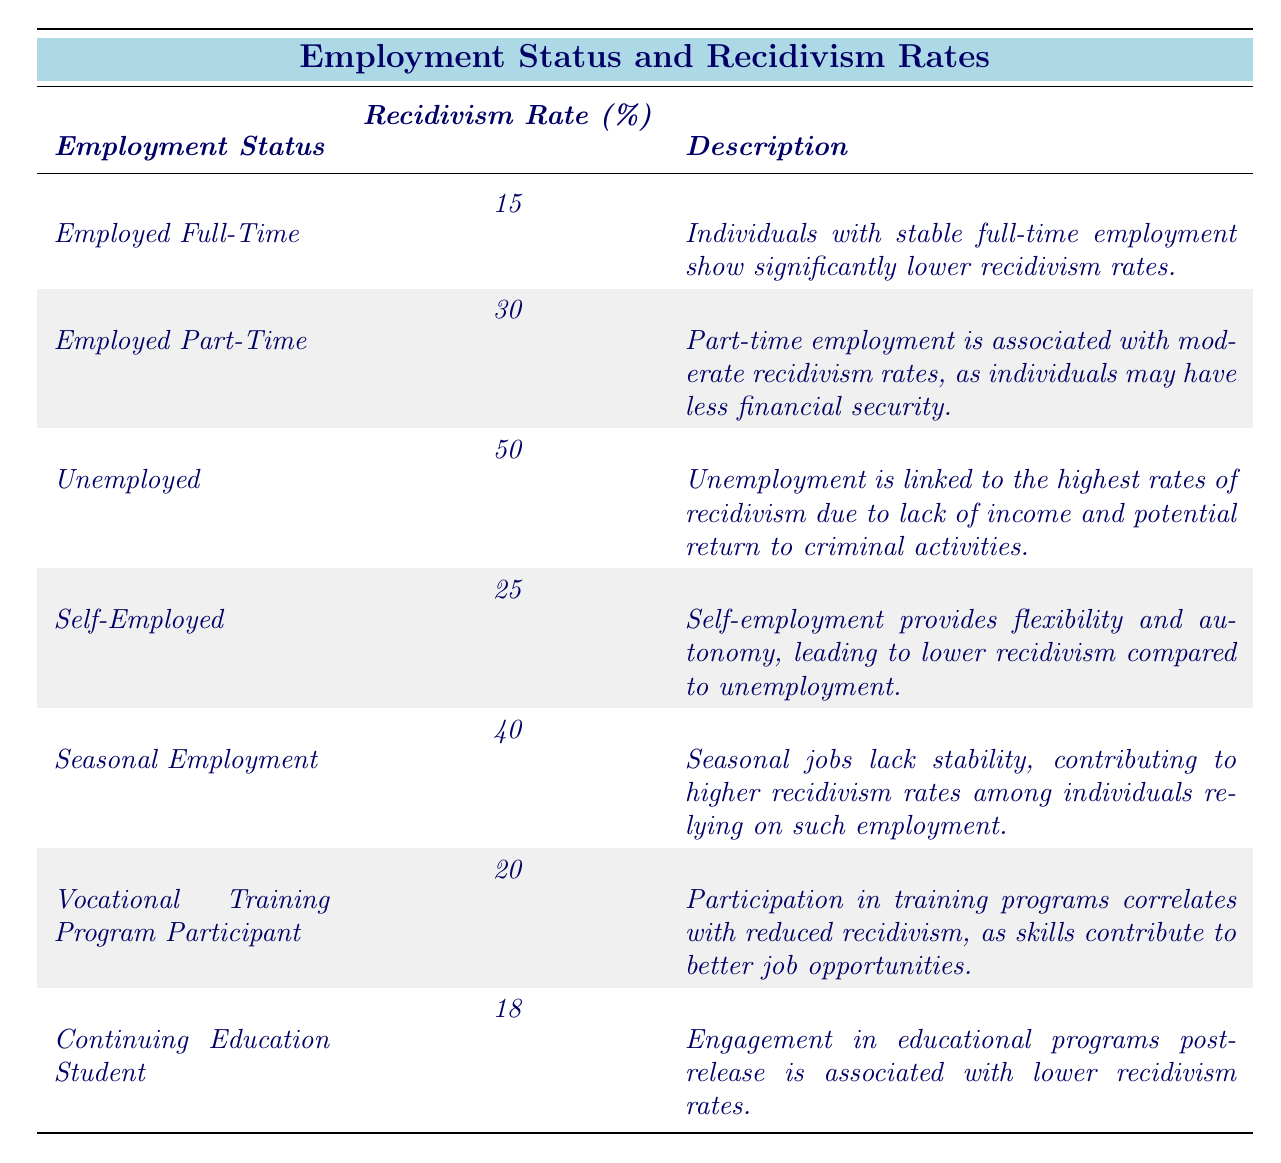What is the recidivism rate for individuals who are unemployed? The table clearly states that the recidivism rate for individuals with the "Unemployed" status is 50%.
Answer: 50% Which employment status has the lowest recidivism rate? According to the table, "Employed Full-Time" has the lowest recidivism rate of 15%.
Answer: Employed Full-Time What is the difference in recidivism rates between those employed full-time and those in seasonal employment? The recidivism rate for "Employed Full-Time" is 15%, and for "Seasonal Employment," it is 40%. The difference is 40 - 15 = 25%.
Answer: 25% Is it true that individuals engaged in vocational training programs have lower recidivism rates than those who are self-employed? From the table, the recidivism rate for "Vocational Training Program Participants" is 20%, while "Self-Employed" individuals have a rate of 25%. Therefore, the statement is true.
Answer: Yes What can be inferred about the relationship between employment status and recidivism rates based on the table? The table shows that as employment stability decreases (from full-time to unemployed), the recidivism rates increase. This suggests a negative correlation between stable employment and recidivism.
Answer: Negative correlation What is the average recidivism rate for individuals who are either self-employed or participating in vocational training programs? The recidivism rate for "Self-Employed" is 25% and for "Vocational Training Program Participant" it is 20%. The average is (25 + 20) / 2 = 22.5%.
Answer: 22.5% Which group has a recidivism rate that is closer to that of full-time employed individuals: continuing education students or those in seasonal employment? "Continuing Education Students" have a recidivism rate of 18%, while "Seasonal Employment" has a rate of 40%. Since 18% is closer to 15% than 40% is, continuing education students are the closer group.
Answer: Continuing Education Students How many employment status categories have a recidivism rate of 30% or higher? The table lists "Employed Part-Time," "Unemployed," "Seasonal Employment," and shows four categories with rates of 30% or higher (30%, 50%, 40%).
Answer: 4 Are part-time employees more likely to recidivate than those who are in vocational training programs? "Employed Part-Time" has a recidivism rate of 30%, while "Vocational Training Program Participants" have a rate of 20%. Therefore, part-time employees are more likely to recidivate.
Answer: Yes 